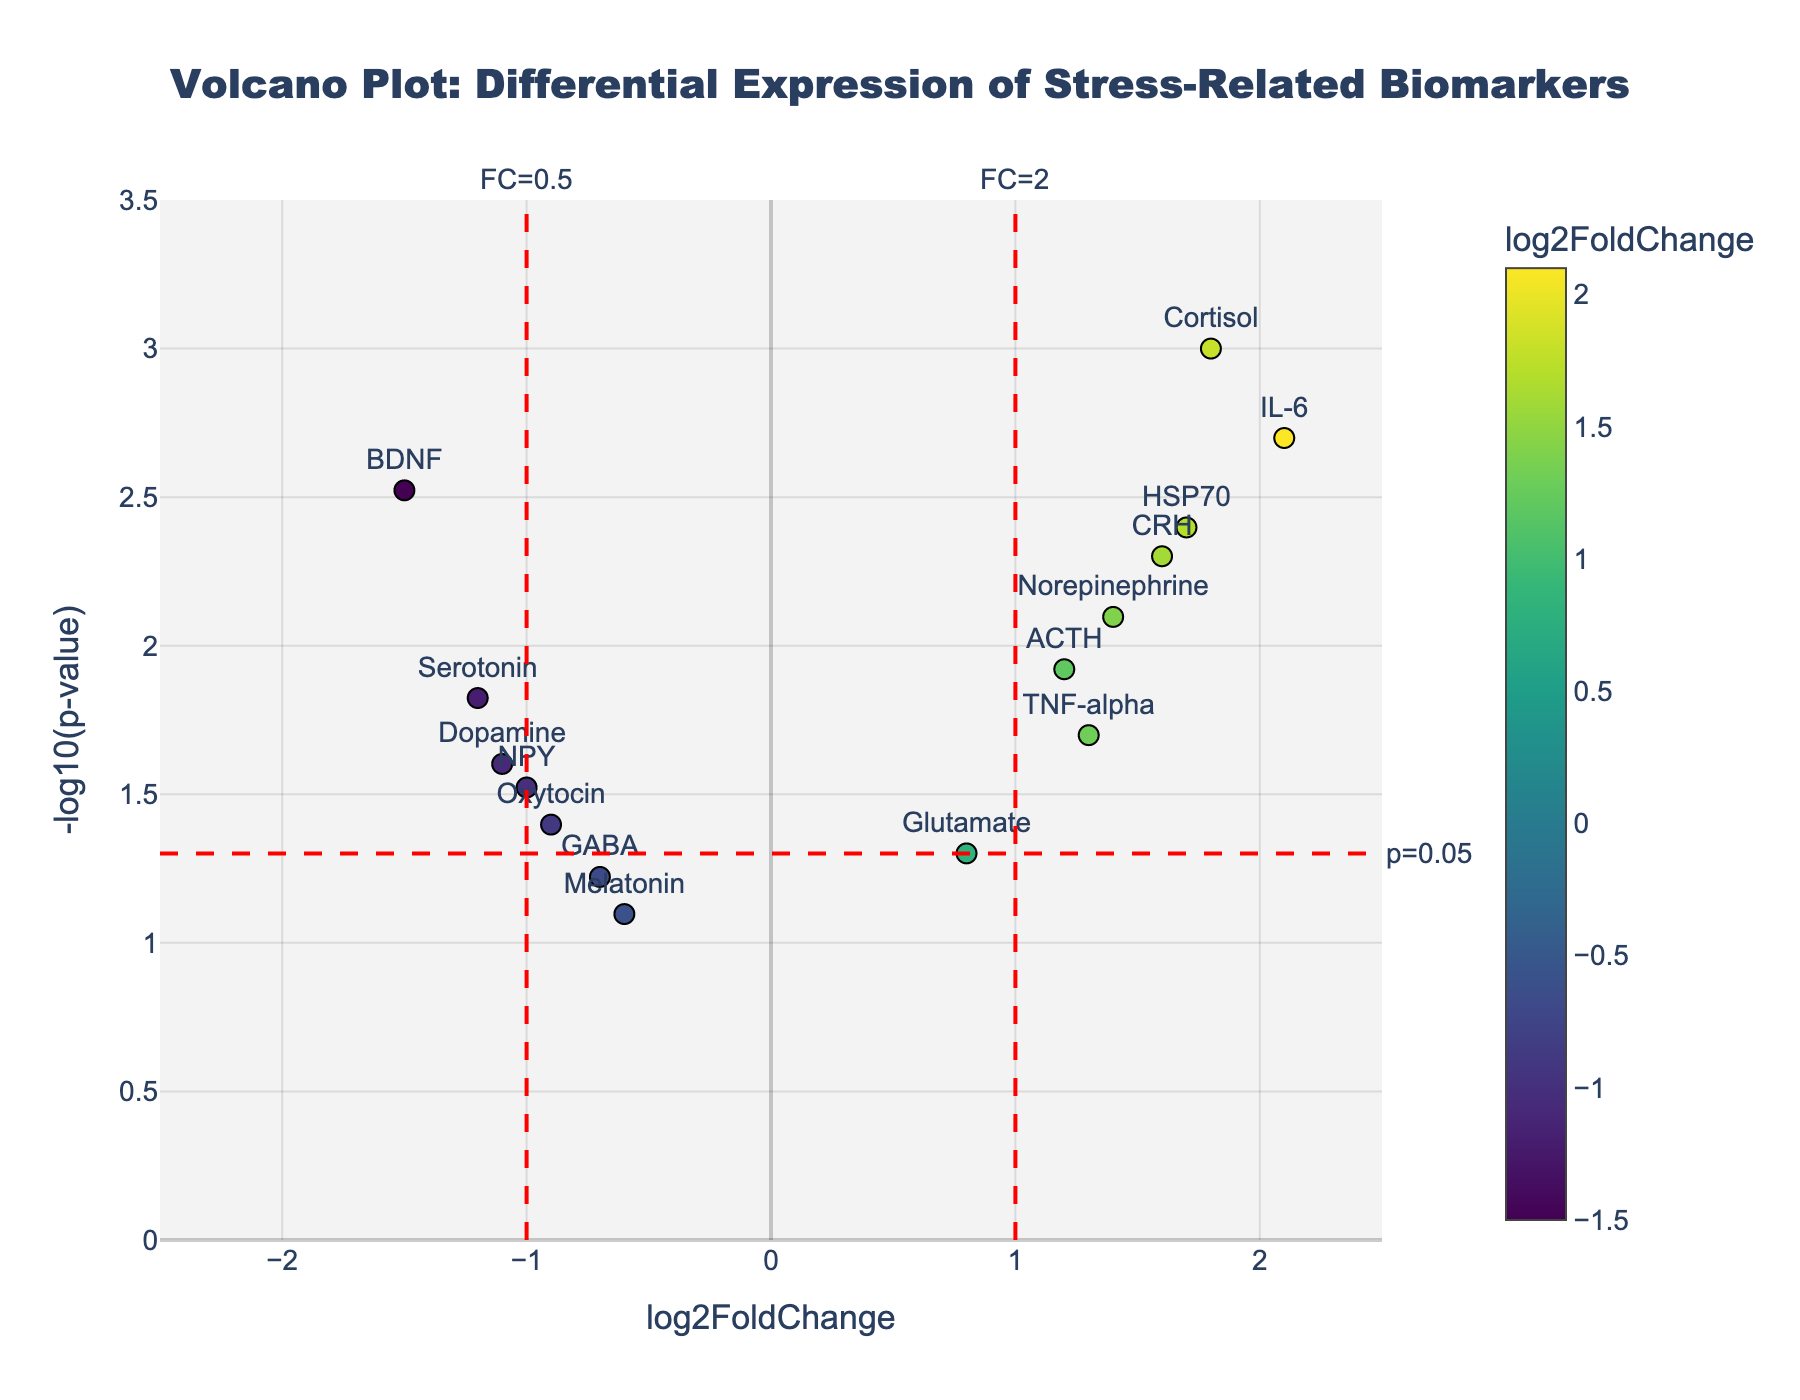How many data points have a -log10(p-value) greater than 2? To determine how many data points have a -log10(p-value) greater than 2, you look at the y-axis of the plot where the value is greater than 2. You will see distinct data points with their respective biomarkers. Count these points.
Answer: 3 Which biomarker has the highest -log10(p-value) and what is its log2FoldChange? To find the biomarker with the highest -log10(p-value), look at the point on the plot with the highest y-axis value. Then observe its corresponding x-axis value and label.
Answer: IL-6, 2.1 Are there any biomarkers with a log2FoldChange greater than 1.5 and a -log10(p-value) less than 3? Review the data points in the plot with log2FoldChange values on the x-axis greater than 1.5, and then check if their -log10(p-value) values on the y-axis are less than 3.
Answer: Yes What is the p-value threshold in the plot? Identify the additional lines drawn apart from the axes; a horizontal line often represents the p-value threshold. Check where this line intersects the y-axis and the annotation near it.
Answer: 0.05 Which biomarkers have a log2FoldChange less than -1 and are considered significant based on the p-value threshold? First, identify biomarkers with a log2FoldChange less than -1 by looking to the left of -1 on the x-axis. Of these, find the ones above the p-value threshold line (-log10(p-value) > 1.3).
Answer: BDNF, Dopamine Which biomarker exhibits the most significant downregulation, and what is its p-value? Look for the biomarker with the most negative log2FoldChange value and check its p-value by referring to its y-axis position.
Answer: BDNF, 0.003 How many biomarkers have p-values less than 0.05 but log2FoldChange values between -1 and 1? Review the plot for data points above the p-value threshold line (-log10(p-value) > 1.3) but within the log2FoldChange range of -1 to 1.
Answer: 4 